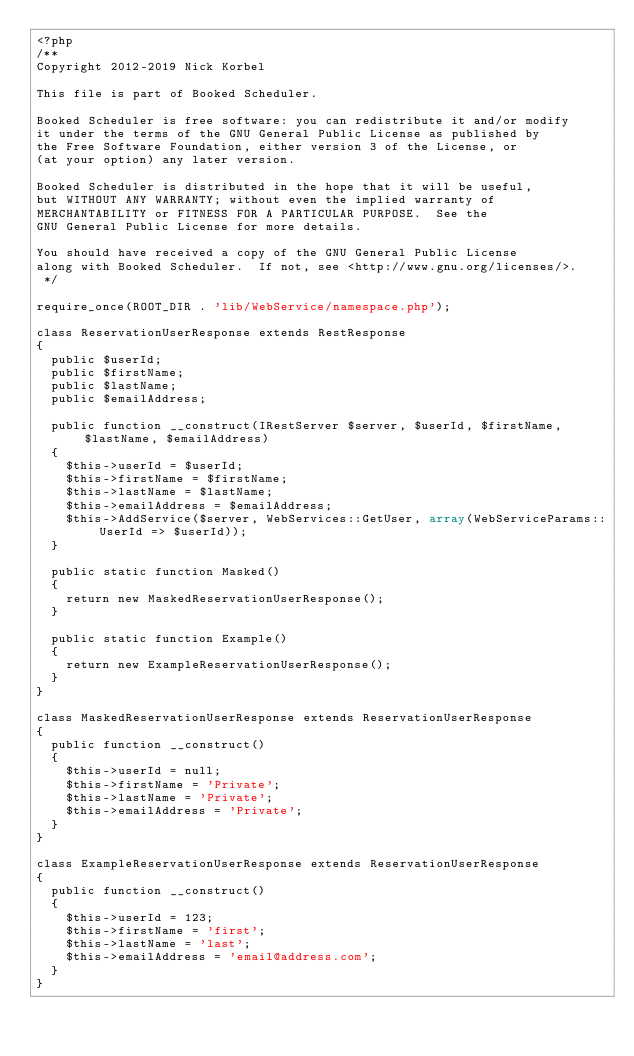Convert code to text. <code><loc_0><loc_0><loc_500><loc_500><_PHP_><?php
/**
Copyright 2012-2019 Nick Korbel

This file is part of Booked Scheduler.

Booked Scheduler is free software: you can redistribute it and/or modify
it under the terms of the GNU General Public License as published by
the Free Software Foundation, either version 3 of the License, or
(at your option) any later version.

Booked Scheduler is distributed in the hope that it will be useful,
but WITHOUT ANY WARRANTY; without even the implied warranty of
MERCHANTABILITY or FITNESS FOR A PARTICULAR PURPOSE.  See the
GNU General Public License for more details.

You should have received a copy of the GNU General Public License
along with Booked Scheduler.  If not, see <http://www.gnu.org/licenses/>.
 */

require_once(ROOT_DIR . 'lib/WebService/namespace.php');

class ReservationUserResponse extends RestResponse
{
	public $userId;
	public $firstName;
	public $lastName;
	public $emailAddress;

	public function __construct(IRestServer $server, $userId, $firstName, $lastName, $emailAddress)
	{
		$this->userId = $userId;
		$this->firstName = $firstName;
		$this->lastName = $lastName;
		$this->emailAddress = $emailAddress;
		$this->AddService($server, WebServices::GetUser, array(WebServiceParams::UserId => $userId));
	}

	public static function Masked()
	{
		return new MaskedReservationUserResponse();
	}

	public static function Example()
	{
		return new ExampleReservationUserResponse();
	}
}

class MaskedReservationUserResponse extends ReservationUserResponse
{
	public function __construct()
	{
		$this->userId = null;
		$this->firstName = 'Private';
		$this->lastName = 'Private';
		$this->emailAddress = 'Private';
	}
}

class ExampleReservationUserResponse extends ReservationUserResponse
{
	public function __construct()
	{
		$this->userId = 123;
		$this->firstName = 'first';
		$this->lastName = 'last';
		$this->emailAddress = 'email@address.com';
	}
}

</code> 